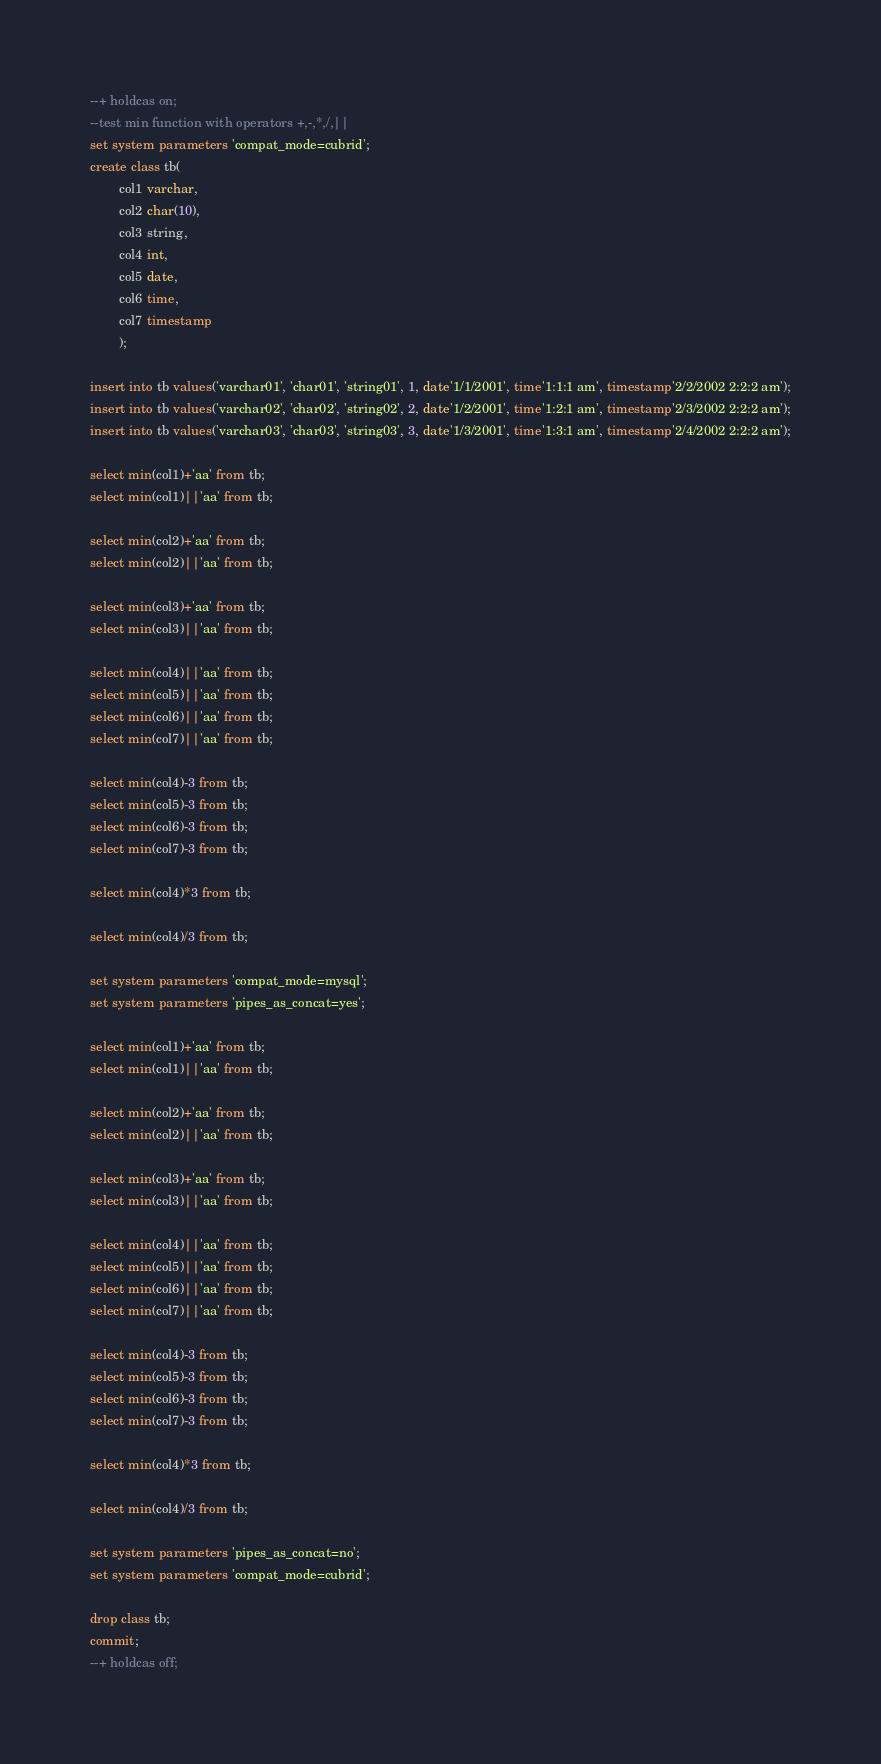<code> <loc_0><loc_0><loc_500><loc_500><_SQL_>--+ holdcas on;
--test min function with operators +,-,*,/,||
set system parameters 'compat_mode=cubrid';
create class tb(
		col1 varchar,
		col2 char(10),
		col3 string,
		col4 int,
		col5 date,
		col6 time,
		col7 timestamp
		);

insert into tb values('varchar01', 'char01', 'string01', 1, date'1/1/2001', time'1:1:1 am', timestamp'2/2/2002 2:2:2 am');
insert into tb values('varchar02', 'char02', 'string02', 2, date'1/2/2001', time'1:2:1 am', timestamp'2/3/2002 2:2:2 am');
insert into tb values('varchar03', 'char03', 'string03', 3, date'1/3/2001', time'1:3:1 am', timestamp'2/4/2002 2:2:2 am');

select min(col1)+'aa' from tb;
select min(col1)||'aa' from tb;

select min(col2)+'aa' from tb;
select min(col2)||'aa' from tb;

select min(col3)+'aa' from tb;
select min(col3)||'aa' from tb;

select min(col4)||'aa' from tb;
select min(col5)||'aa' from tb;
select min(col6)||'aa' from tb;
select min(col7)||'aa' from tb;

select min(col4)-3 from tb;
select min(col5)-3 from tb;
select min(col6)-3 from tb;
select min(col7)-3 from tb;

select min(col4)*3 from tb;

select min(col4)/3 from tb;

set system parameters 'compat_mode=mysql';
set system parameters 'pipes_as_concat=yes';

select min(col1)+'aa' from tb;
select min(col1)||'aa' from tb;

select min(col2)+'aa' from tb;
select min(col2)||'aa' from tb;

select min(col3)+'aa' from tb;
select min(col3)||'aa' from tb;

select min(col4)||'aa' from tb;
select min(col5)||'aa' from tb;
select min(col6)||'aa' from tb;
select min(col7)||'aa' from tb;

select min(col4)-3 from tb;
select min(col5)-3 from tb;
select min(col6)-3 from tb;
select min(col7)-3 from tb;

select min(col4)*3 from tb;

select min(col4)/3 from tb;

set system parameters 'pipes_as_concat=no';
set system parameters 'compat_mode=cubrid';

drop class tb;
commit;
--+ holdcas off;
</code> 